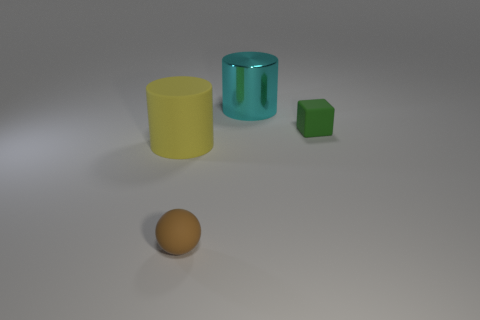Add 2 big cylinders. How many objects exist? 6 Subtract all cubes. How many objects are left? 3 Subtract all big yellow rubber cylinders. Subtract all blocks. How many objects are left? 2 Add 2 cylinders. How many cylinders are left? 4 Add 4 small purple metallic blocks. How many small purple metallic blocks exist? 4 Subtract 0 purple cylinders. How many objects are left? 4 